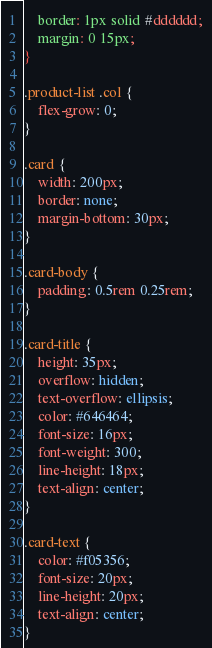<code> <loc_0><loc_0><loc_500><loc_500><_CSS_>    border: 1px solid #dddddd;
    margin: 0 15px;
}

.product-list .col {
    flex-grow: 0;
}

.card {
    width: 200px;
    border: none;
    margin-bottom: 30px;
}

.card-body {
    padding: 0.5rem 0.25rem;
}

.card-title {
    height: 35px;
    overflow: hidden;
    text-overflow: ellipsis;
    color: #646464;
    font-size: 16px;
    font-weight: 300;
    line-height: 18px;
    text-align: center;
}

.card-text {
    color: #f05356;
    font-size: 20px;
    line-height: 20px;
    text-align: center;
}
</code> 